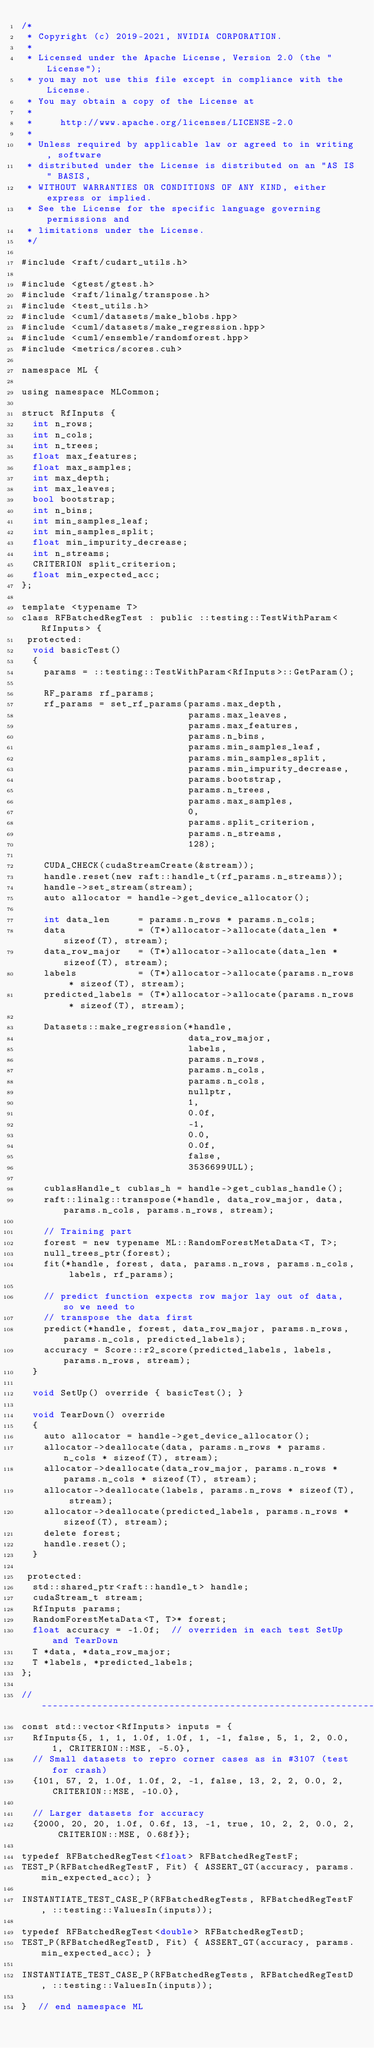Convert code to text. <code><loc_0><loc_0><loc_500><loc_500><_Cuda_>/*
 * Copyright (c) 2019-2021, NVIDIA CORPORATION.
 *
 * Licensed under the Apache License, Version 2.0 (the "License");
 * you may not use this file except in compliance with the License.
 * You may obtain a copy of the License at
 *
 *     http://www.apache.org/licenses/LICENSE-2.0
 *
 * Unless required by applicable law or agreed to in writing, software
 * distributed under the License is distributed on an "AS IS" BASIS,
 * WITHOUT WARRANTIES OR CONDITIONS OF ANY KIND, either express or implied.
 * See the License for the specific language governing permissions and
 * limitations under the License.
 */

#include <raft/cudart_utils.h>

#include <gtest/gtest.h>
#include <raft/linalg/transpose.h>
#include <test_utils.h>
#include <cuml/datasets/make_blobs.hpp>
#include <cuml/datasets/make_regression.hpp>
#include <cuml/ensemble/randomforest.hpp>
#include <metrics/scores.cuh>

namespace ML {

using namespace MLCommon;

struct RfInputs {
  int n_rows;
  int n_cols;
  int n_trees;
  float max_features;
  float max_samples;
  int max_depth;
  int max_leaves;
  bool bootstrap;
  int n_bins;
  int min_samples_leaf;
  int min_samples_split;
  float min_impurity_decrease;
  int n_streams;
  CRITERION split_criterion;
  float min_expected_acc;
};

template <typename T>
class RFBatchedRegTest : public ::testing::TestWithParam<RfInputs> {
 protected:
  void basicTest()
  {
    params = ::testing::TestWithParam<RfInputs>::GetParam();

    RF_params rf_params;
    rf_params = set_rf_params(params.max_depth,
                              params.max_leaves,
                              params.max_features,
                              params.n_bins,
                              params.min_samples_leaf,
                              params.min_samples_split,
                              params.min_impurity_decrease,
                              params.bootstrap,
                              params.n_trees,
                              params.max_samples,
                              0,
                              params.split_criterion,
                              params.n_streams,
                              128);

    CUDA_CHECK(cudaStreamCreate(&stream));
    handle.reset(new raft::handle_t(rf_params.n_streams));
    handle->set_stream(stream);
    auto allocator = handle->get_device_allocator();

    int data_len     = params.n_rows * params.n_cols;
    data             = (T*)allocator->allocate(data_len * sizeof(T), stream);
    data_row_major   = (T*)allocator->allocate(data_len * sizeof(T), stream);
    labels           = (T*)allocator->allocate(params.n_rows * sizeof(T), stream);
    predicted_labels = (T*)allocator->allocate(params.n_rows * sizeof(T), stream);

    Datasets::make_regression(*handle,
                              data_row_major,
                              labels,
                              params.n_rows,
                              params.n_cols,
                              params.n_cols,
                              nullptr,
                              1,
                              0.0f,
                              -1,
                              0.0,
                              0.0f,
                              false,
                              3536699ULL);

    cublasHandle_t cublas_h = handle->get_cublas_handle();
    raft::linalg::transpose(*handle, data_row_major, data, params.n_cols, params.n_rows, stream);

    // Training part
    forest = new typename ML::RandomForestMetaData<T, T>;
    null_trees_ptr(forest);
    fit(*handle, forest, data, params.n_rows, params.n_cols, labels, rf_params);

    // predict function expects row major lay out of data, so we need to
    // transpose the data first
    predict(*handle, forest, data_row_major, params.n_rows, params.n_cols, predicted_labels);
    accuracy = Score::r2_score(predicted_labels, labels, params.n_rows, stream);
  }

  void SetUp() override { basicTest(); }

  void TearDown() override
  {
    auto allocator = handle->get_device_allocator();
    allocator->deallocate(data, params.n_rows * params.n_cols * sizeof(T), stream);
    allocator->deallocate(data_row_major, params.n_rows * params.n_cols * sizeof(T), stream);
    allocator->deallocate(labels, params.n_rows * sizeof(T), stream);
    allocator->deallocate(predicted_labels, params.n_rows * sizeof(T), stream);
    delete forest;
    handle.reset();
  }

 protected:
  std::shared_ptr<raft::handle_t> handle;
  cudaStream_t stream;
  RfInputs params;
  RandomForestMetaData<T, T>* forest;
  float accuracy = -1.0f;  // overriden in each test SetUp and TearDown
  T *data, *data_row_major;
  T *labels, *predicted_labels;
};

//-------------------------------------------------------------------------------------------------------------------------------------
const std::vector<RfInputs> inputs = {
  RfInputs{5, 1, 1, 1.0f, 1.0f, 1, -1, false, 5, 1, 2, 0.0, 1, CRITERION::MSE, -5.0},
  // Small datasets to repro corner cases as in #3107 (test for crash)
  {101, 57, 2, 1.0f, 1.0f, 2, -1, false, 13, 2, 2, 0.0, 2, CRITERION::MSE, -10.0},

  // Larger datasets for accuracy
  {2000, 20, 20, 1.0f, 0.6f, 13, -1, true, 10, 2, 2, 0.0, 2, CRITERION::MSE, 0.68f}};

typedef RFBatchedRegTest<float> RFBatchedRegTestF;
TEST_P(RFBatchedRegTestF, Fit) { ASSERT_GT(accuracy, params.min_expected_acc); }

INSTANTIATE_TEST_CASE_P(RFBatchedRegTests, RFBatchedRegTestF, ::testing::ValuesIn(inputs));

typedef RFBatchedRegTest<double> RFBatchedRegTestD;
TEST_P(RFBatchedRegTestD, Fit) { ASSERT_GT(accuracy, params.min_expected_acc); }

INSTANTIATE_TEST_CASE_P(RFBatchedRegTests, RFBatchedRegTestD, ::testing::ValuesIn(inputs));

}  // end namespace ML
</code> 